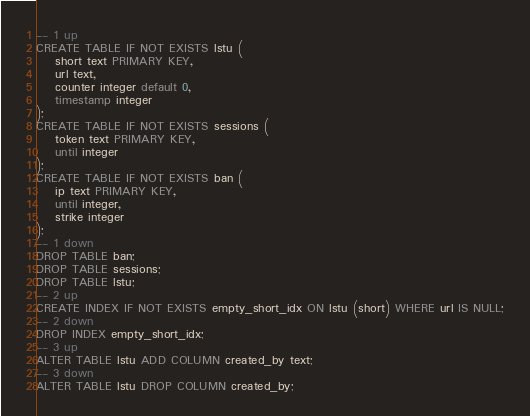Convert code to text. <code><loc_0><loc_0><loc_500><loc_500><_SQL_>-- 1 up
CREATE TABLE IF NOT EXISTS lstu (
    short text PRIMARY KEY,
    url text,
    counter integer default 0,
    timestamp integer
);
CREATE TABLE IF NOT EXISTS sessions (
    token text PRIMARY KEY,
    until integer
);
CREATE TABLE IF NOT EXISTS ban (
    ip text PRIMARY KEY,
    until integer,
    strike integer
);
-- 1 down
DROP TABLE ban;
DROP TABLE sessions;
DROP TABLE lstu;
-- 2 up
CREATE INDEX IF NOT EXISTS empty_short_idx ON lstu (short) WHERE url IS NULL;
-- 2 down
DROP INDEX empty_short_idx;
-- 3 up
ALTER TABLE lstu ADD COLUMN created_by text;
-- 3 down
ALTER TABLE lstu DROP COLUMN created_by;
</code> 